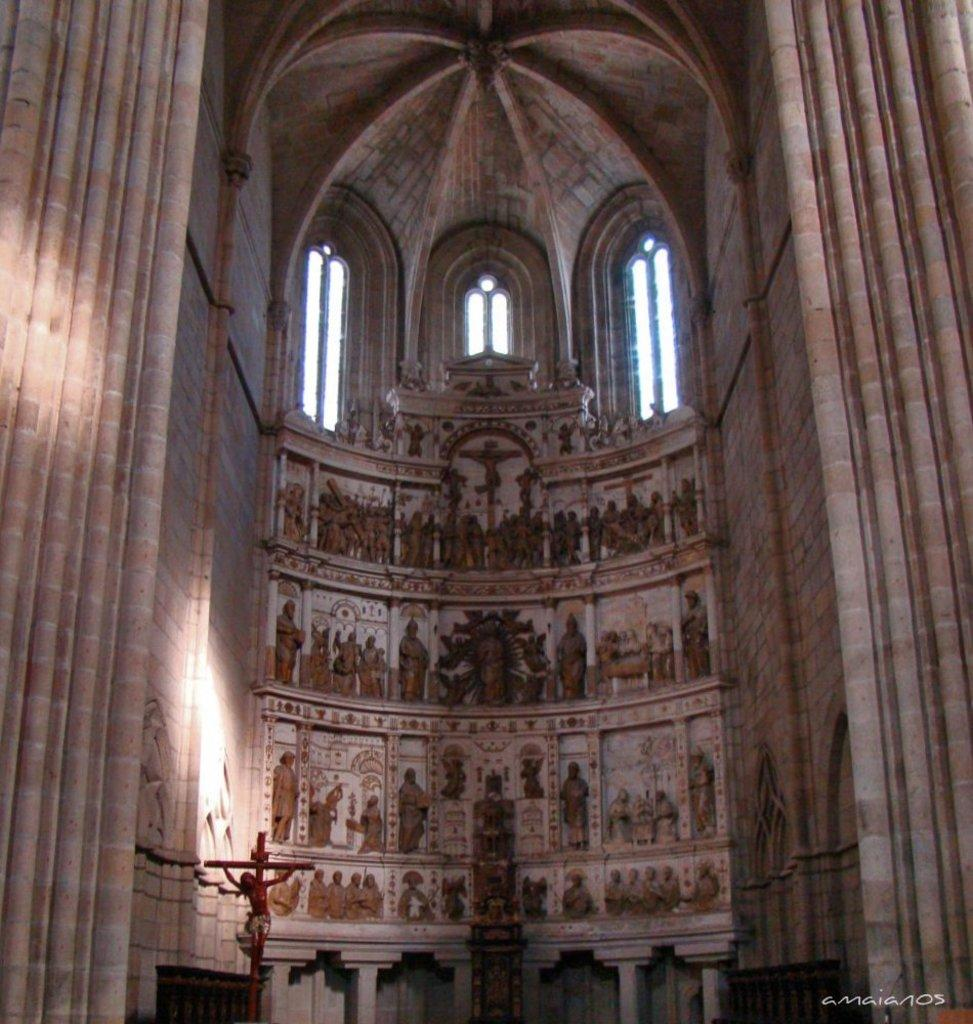What is the main subject in the foreground of the image? There is a fort wall in the foreground of the image. What can be seen on the fort wall? There are sculptures and windows visible on the fort wall. Is there any text in the image? Yes, there is a text in the bottom right corner of the image. Where was the image taken? The image was taken in a fort. Can you see the mom running with a ball in the image? There is no mom or ball present in the image; it features a fort wall with sculptures and windows. 